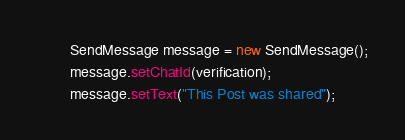Convert code to text. <code><loc_0><loc_0><loc_500><loc_500><_Java_>        SendMessage message = new SendMessage();
        message.setChatId(verification);
        message.setText("This Post was shared");
</code> 